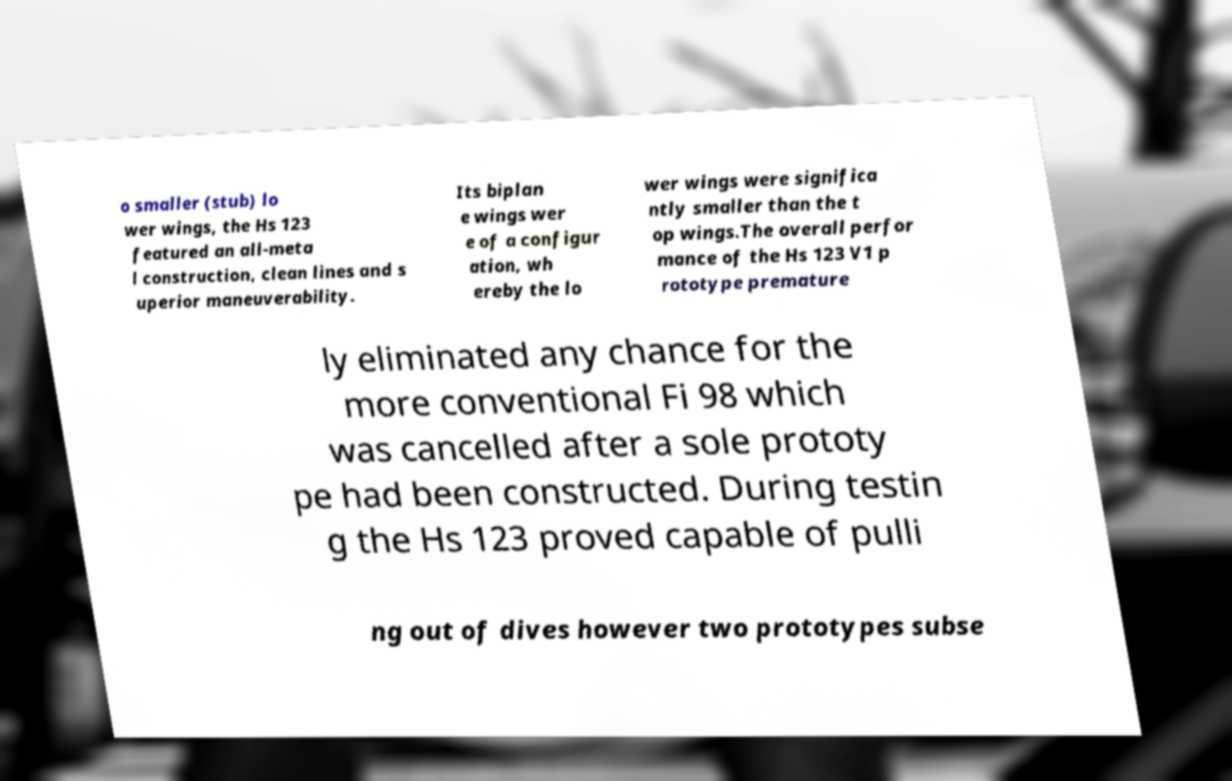Could you assist in decoding the text presented in this image and type it out clearly? o smaller (stub) lo wer wings, the Hs 123 featured an all-meta l construction, clean lines and s uperior maneuverability. Its biplan e wings wer e of a configur ation, wh ereby the lo wer wings were significa ntly smaller than the t op wings.The overall perfor mance of the Hs 123 V1 p rototype premature ly eliminated any chance for the more conventional Fi 98 which was cancelled after a sole prototy pe had been constructed. During testin g the Hs 123 proved capable of pulli ng out of dives however two prototypes subse 